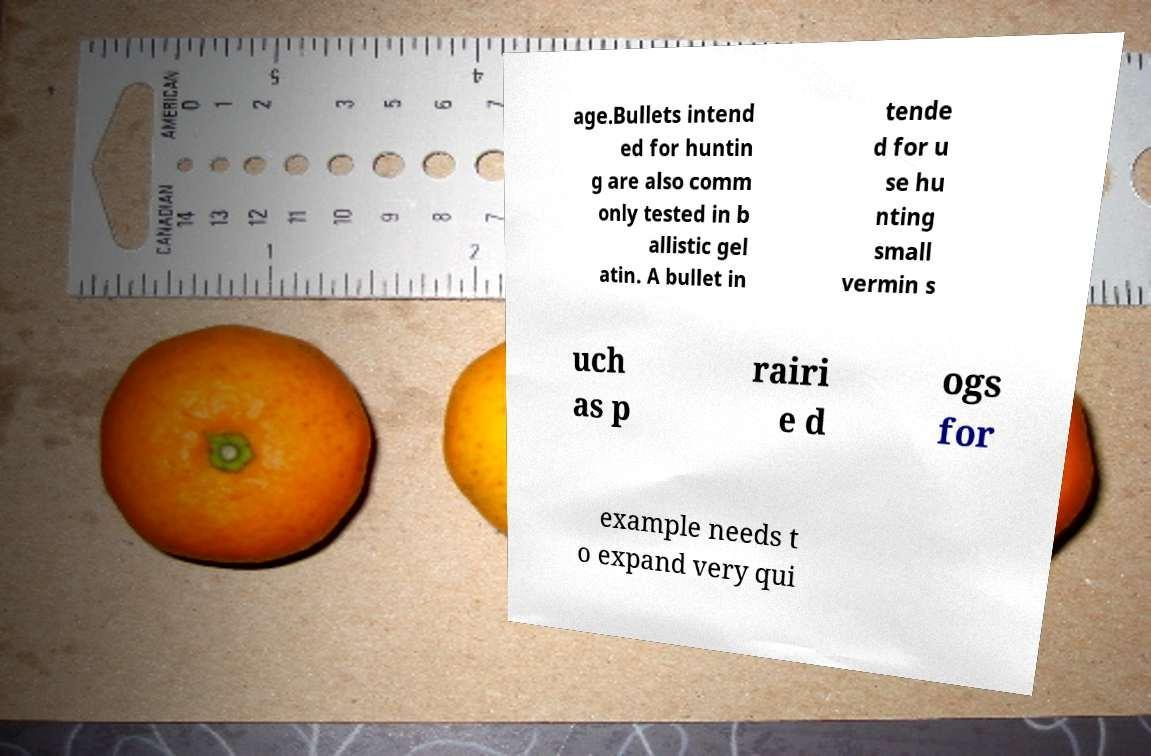Could you assist in decoding the text presented in this image and type it out clearly? age.Bullets intend ed for huntin g are also comm only tested in b allistic gel atin. A bullet in tende d for u se hu nting small vermin s uch as p rairi e d ogs for example needs t o expand very qui 